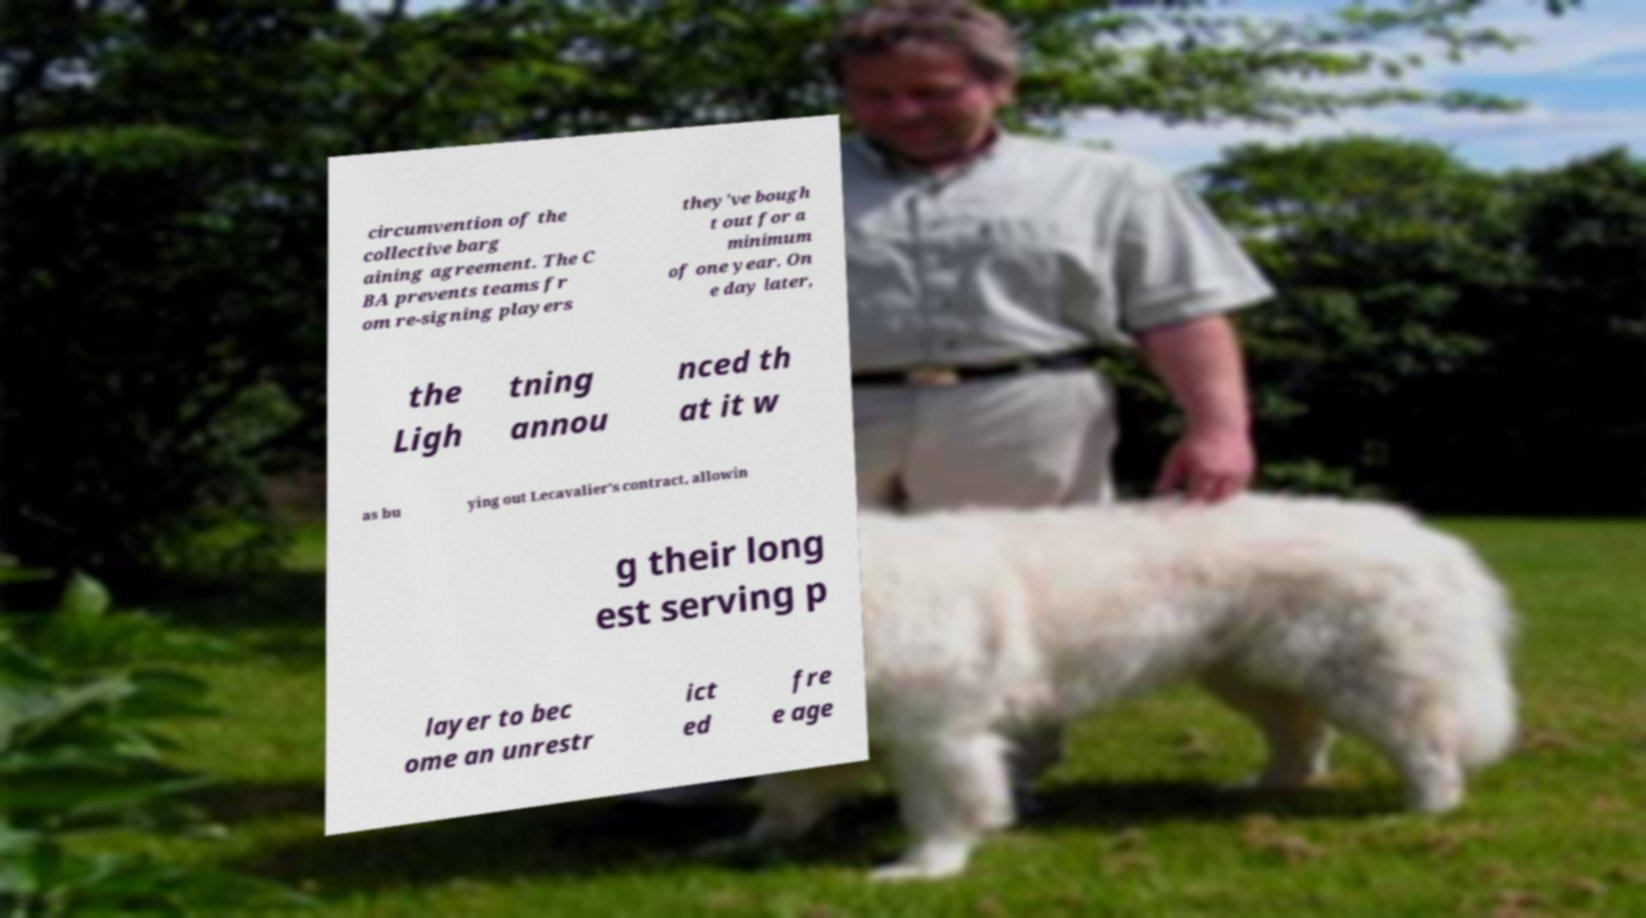Can you accurately transcribe the text from the provided image for me? circumvention of the collective barg aining agreement. The C BA prevents teams fr om re-signing players they've bough t out for a minimum of one year. On e day later, the Ligh tning annou nced th at it w as bu ying out Lecavalier's contract, allowin g their long est serving p layer to bec ome an unrestr ict ed fre e age 